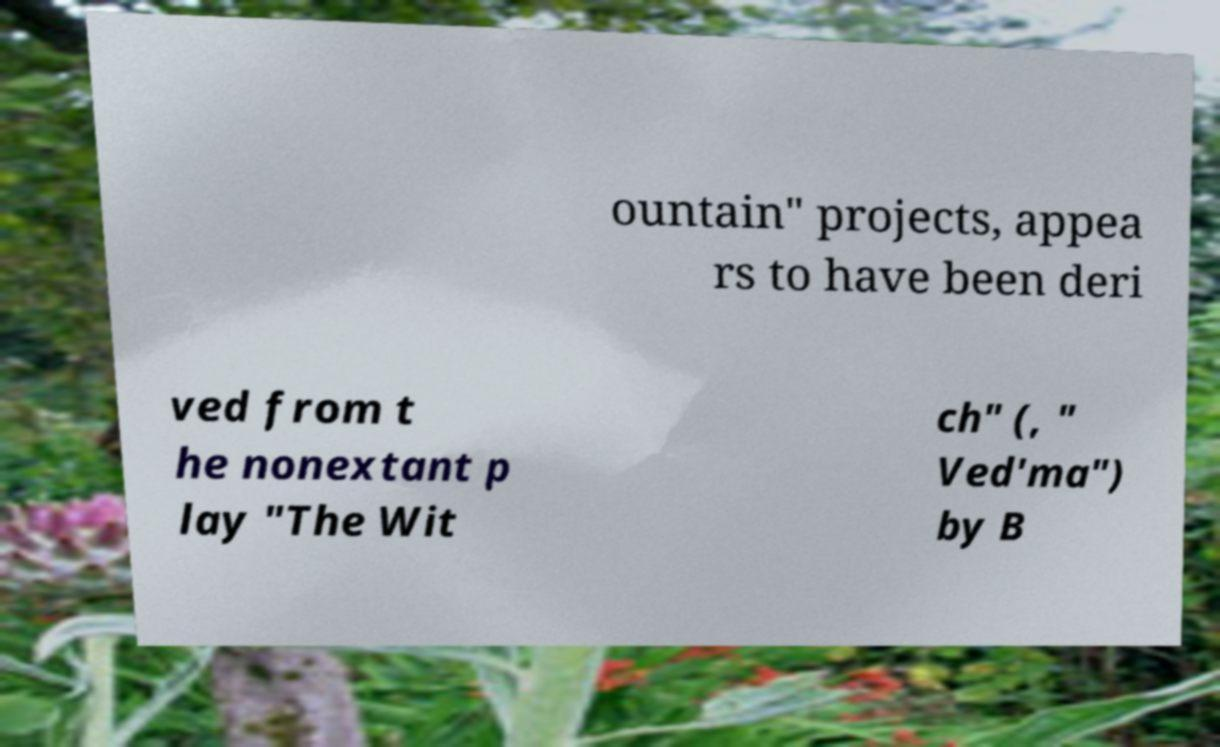There's text embedded in this image that I need extracted. Can you transcribe it verbatim? ountain" projects, appea rs to have been deri ved from t he nonextant p lay "The Wit ch" (, " Ved′ma") by B 